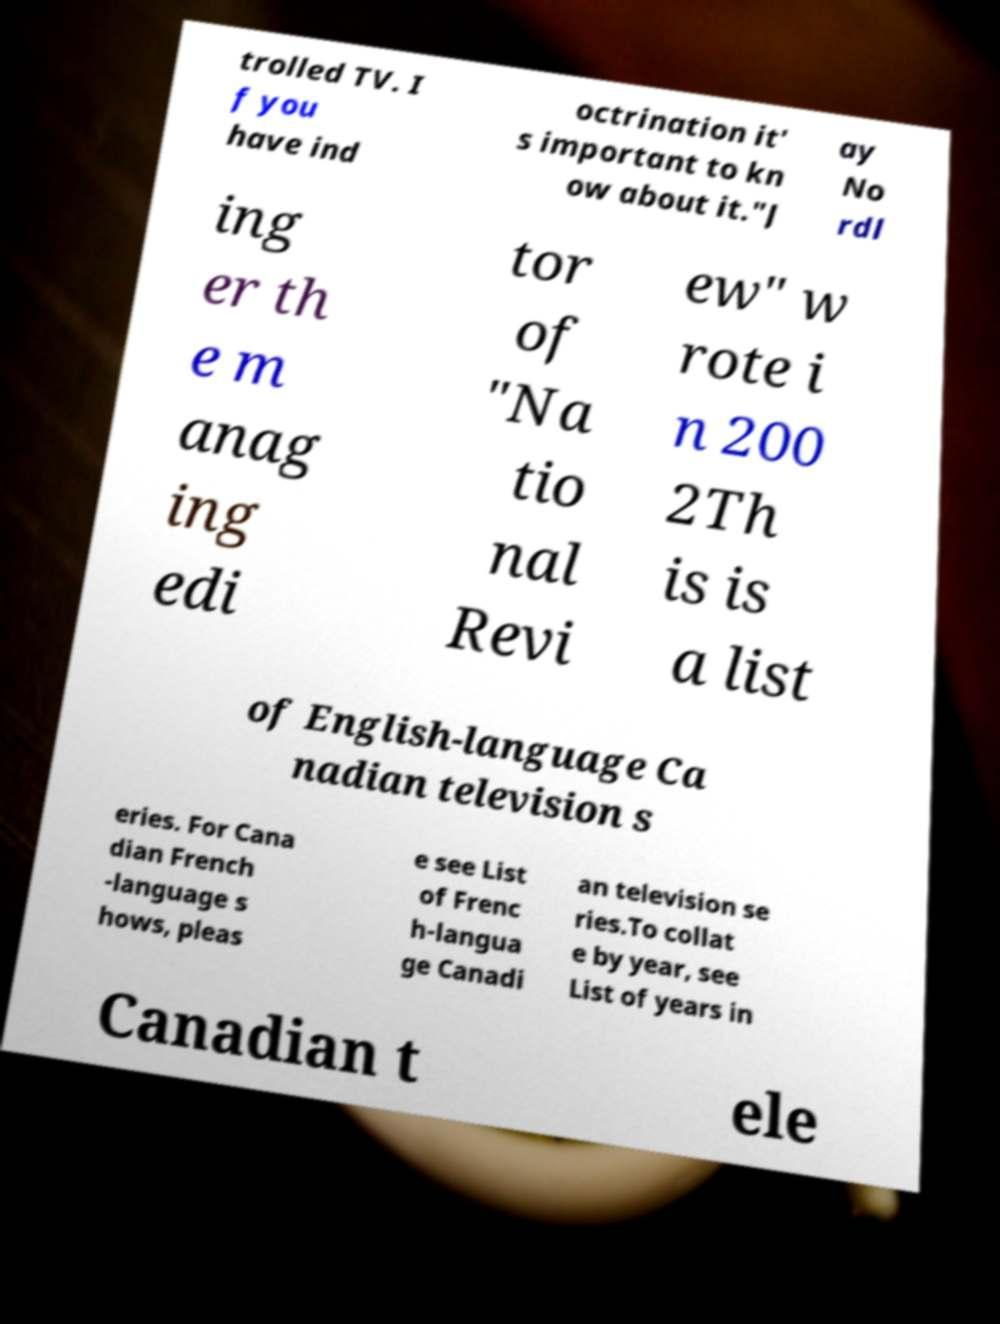Please read and relay the text visible in this image. What does it say? trolled TV. I f you have ind octrination it' s important to kn ow about it."J ay No rdl ing er th e m anag ing edi tor of "Na tio nal Revi ew" w rote i n 200 2Th is is a list of English-language Ca nadian television s eries. For Cana dian French -language s hows, pleas e see List of Frenc h-langua ge Canadi an television se ries.To collat e by year, see List of years in Canadian t ele 